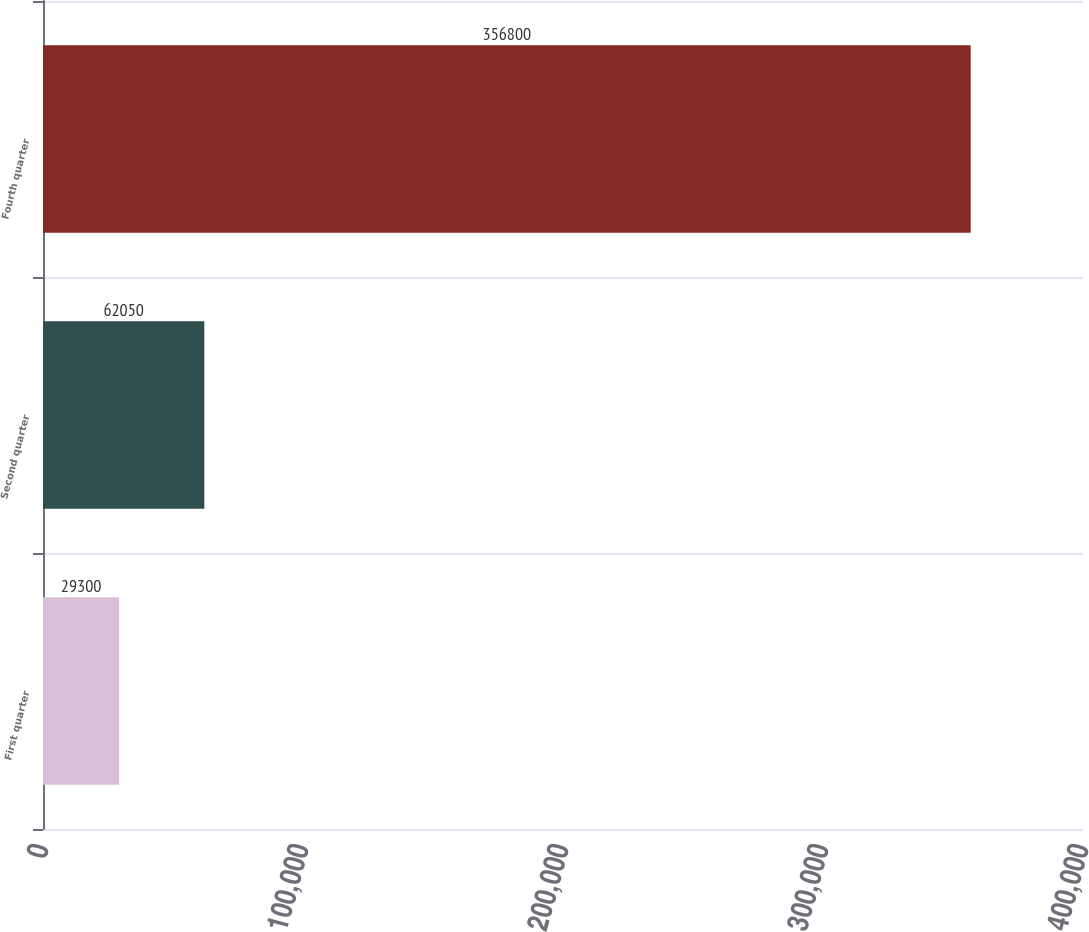Convert chart. <chart><loc_0><loc_0><loc_500><loc_500><bar_chart><fcel>First quarter<fcel>Second quarter<fcel>Fourth quarter<nl><fcel>29300<fcel>62050<fcel>356800<nl></chart> 